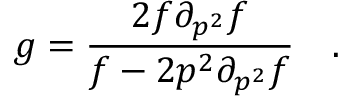Convert formula to latex. <formula><loc_0><loc_0><loc_500><loc_500>g = \frac { 2 f \partial _ { p ^ { 2 } } f } { f - 2 p ^ { 2 } \partial _ { p ^ { 2 } } f } \quad .</formula> 